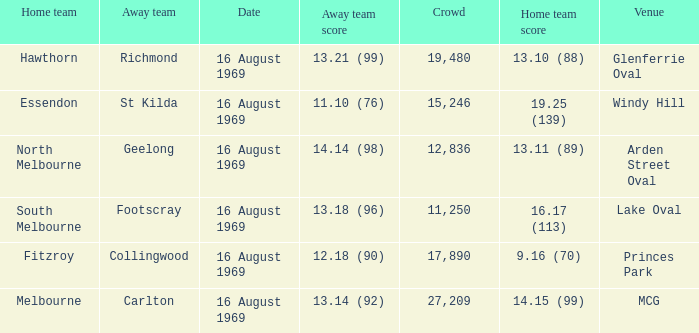When was the game played at Lake Oval? 16 August 1969. 